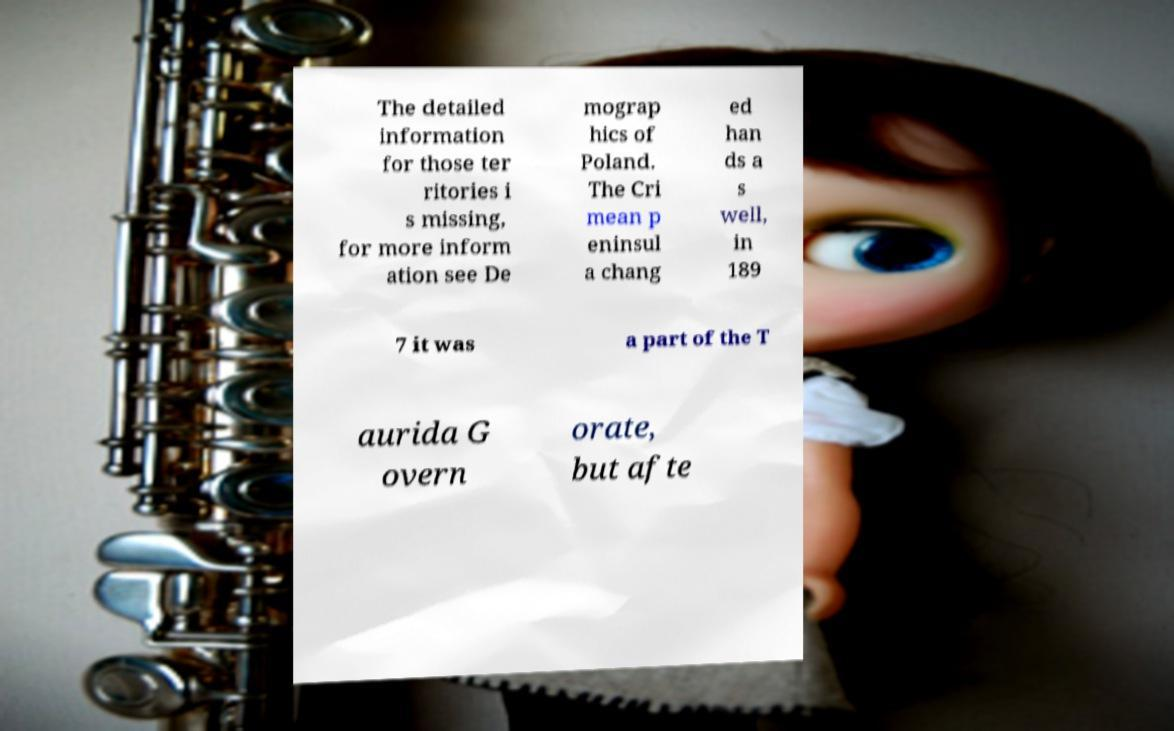Could you assist in decoding the text presented in this image and type it out clearly? The detailed information for those ter ritories i s missing, for more inform ation see De mograp hics of Poland. The Cri mean p eninsul a chang ed han ds a s well, in 189 7 it was a part of the T aurida G overn orate, but afte 